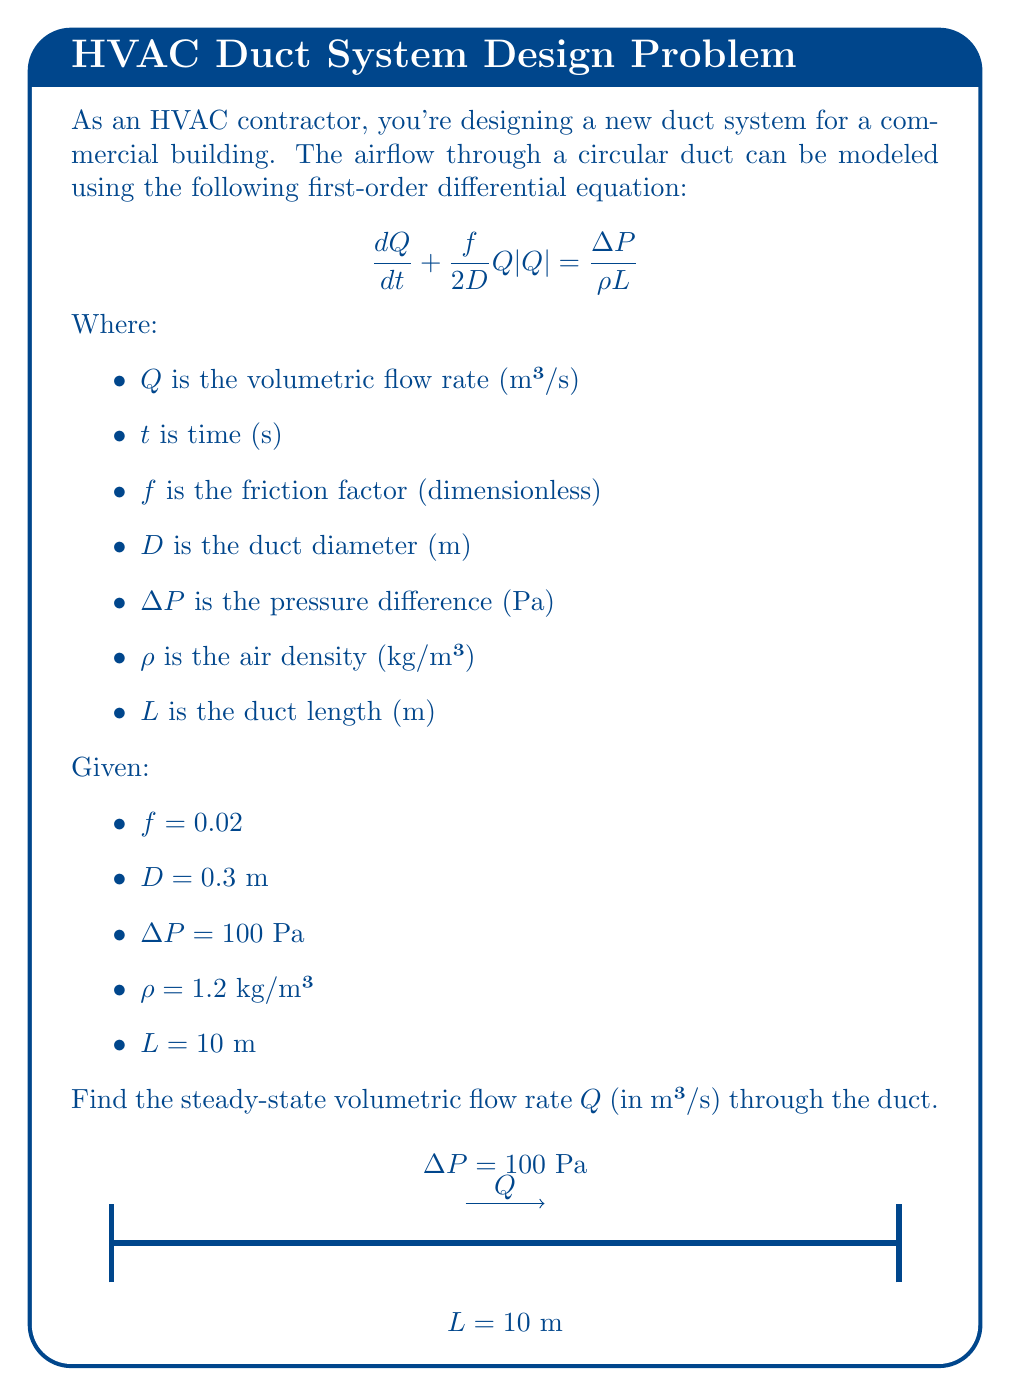Teach me how to tackle this problem. To find the steady-state flow rate, we need to solve the differential equation when $\frac{dQ}{dt} = 0$, as the flow rate is not changing over time in steady-state conditions.

Step 1: Set $\frac{dQ}{dt} = 0$ in the original equation:
$$0 + \frac{f}{2D}Q|Q| = \frac{\Delta P}{\rho L}$$

Step 2: Rearrange the equation to solve for $Q$:
$$\frac{f}{2D}Q|Q| = \frac{\Delta P}{\rho L}$$
$$Q|Q| = \frac{2D\Delta P}{f\rho L}$$

Step 3: Take the square root of both sides. Since we're dealing with flow rate, we'll use the positive root:
$$Q = \sqrt{\frac{2D\Delta P}{f\rho L}}$$

Step 4: Substitute the given values:
$$Q = \sqrt{\frac{2 \cdot 0.3 \cdot 100}{0.02 \cdot 1.2 \cdot 10}}$$

Step 5: Calculate the result:
$$Q = \sqrt{\frac{60}{0.24}} = \sqrt{250} = 15.81$$

Therefore, the steady-state volumetric flow rate is approximately 15.81 m³/s.
Answer: $15.81$ m³/s 